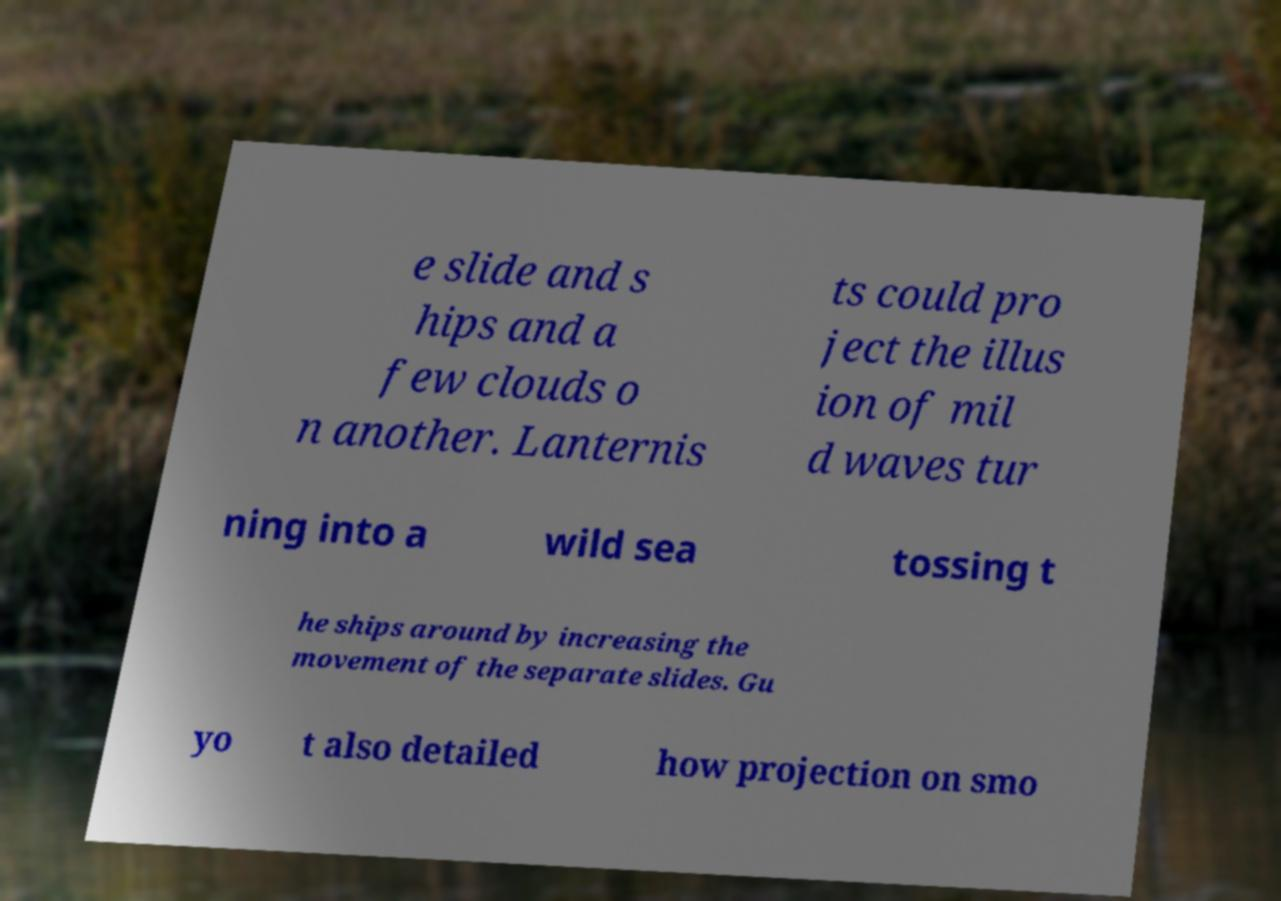Can you accurately transcribe the text from the provided image for me? e slide and s hips and a few clouds o n another. Lanternis ts could pro ject the illus ion of mil d waves tur ning into a wild sea tossing t he ships around by increasing the movement of the separate slides. Gu yo t also detailed how projection on smo 